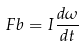<formula> <loc_0><loc_0><loc_500><loc_500>F b = I \frac { d \omega } { d t }</formula> 